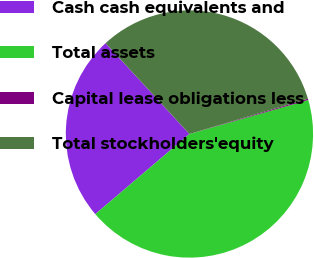Convert chart. <chart><loc_0><loc_0><loc_500><loc_500><pie_chart><fcel>Cash cash equivalents and<fcel>Total assets<fcel>Capital lease obligations less<fcel>Total stockholders'equity<nl><fcel>24.36%<fcel>43.21%<fcel>0.17%<fcel>32.26%<nl></chart> 